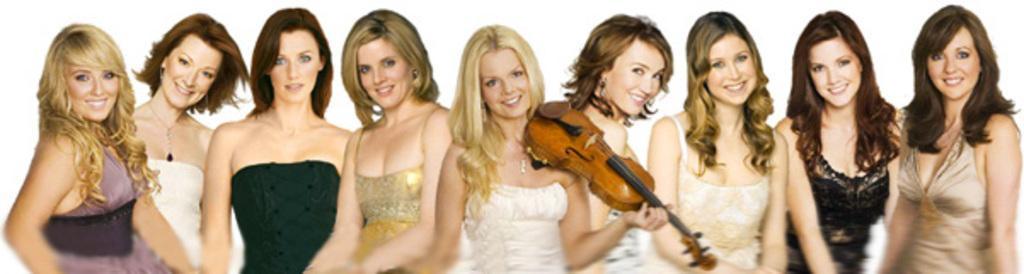How would you summarize this image in a sentence or two? As we can see in the image there are group of people. The woman who is standing in the middle is holding guitar. 